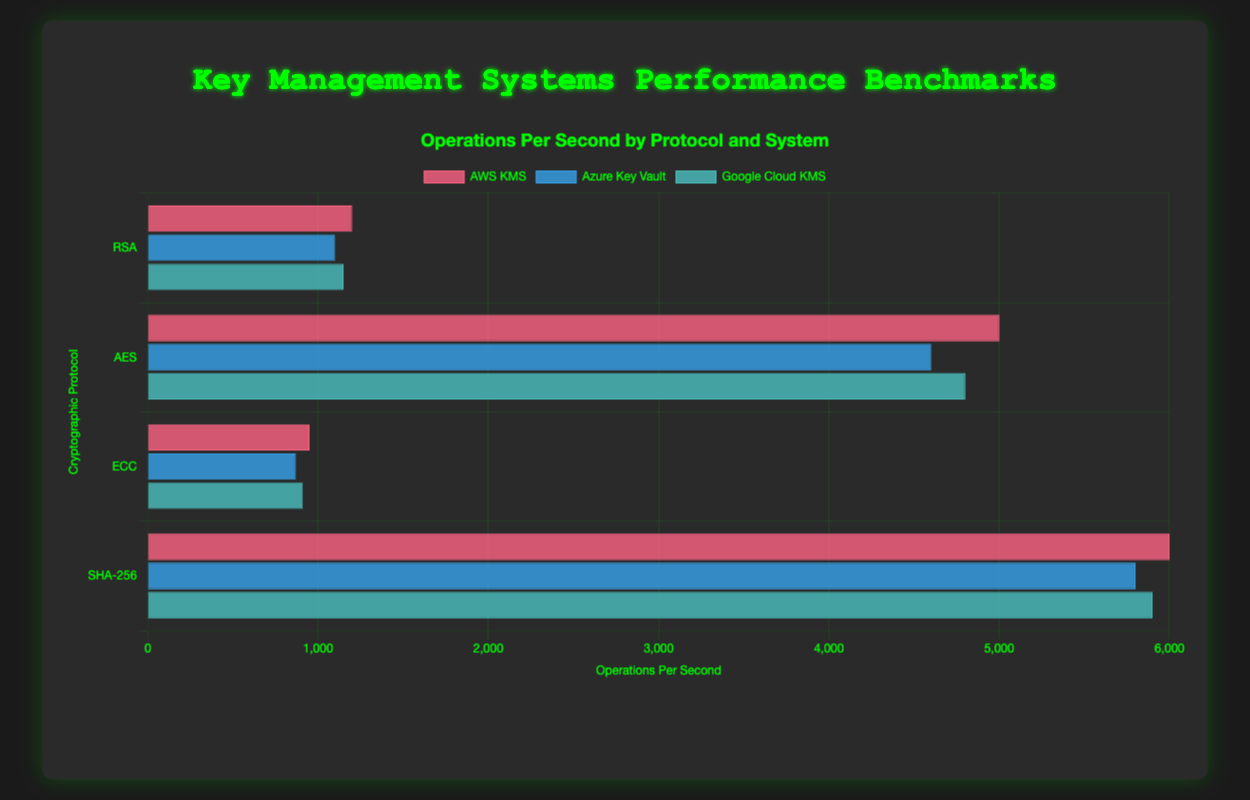Which Key Management System shows the highest operations per second for the RSA protocol? Look at the RSA protocol section and compare the operations per second of AWS KMS, Azure Key Vault, and Google Cloud KMS. AWS KMS has the highest value at 1200 operations per second.
Answer: AWS KMS How does the latency of Google Cloud KMS compare to Azure Key Vault for the AES protocol? For the AES protocol, Google Cloud KMS has a latency of 6 ms while Azure Key Vault has a latency of 7 ms. Google Cloud KMS has lower latency by 1 ms.
Answer: Google Cloud KMS has lower latency Between AWS KMS and Azure Key Vault, which system has a more significant difference in operations per second between AES and ECC protocols? Calculate the difference in operations per second for both systems across AES and ECC. For AWS KMS, the difference is 5000 - 950 = 4050. For Azure Key Vault, the difference is 4600 - 870 = 3730. AWS KMS has a greater difference.
Answer: AWS KMS Which cryptographic protocol has the least variation in operations per second among the three KMS systems? Compare the variation in operations per second within each protocol. For RSA, the range is 1200 - 1100 = 100. For AES, the range is 5000 - 4600 = 400. For ECC, the range is 950 - 870 = 80. For SHA-256, the range is 6000 - 5800 = 200. ECC has the least variation.
Answer: ECC What is the average latency for the RSA protocol across all systems? To find the average, sum the latencies and divide by the number of systems. (20 ms + 25 ms + 22 ms)/3 = 67 ms / 3 = 22.33 ms.
Answer: 22.33 ms Which system has the highest operations per second for the SHA-256 protocol, and what is its value? Refer to the SHA-256 protocol section and identify the system with the highest operations per second. AWS KMS has the highest value at 6000 operations per second.
Answer: AWS KMS, 6000 operations per second Compare the latency of AWS KMS between the RSA and SHA-256 protocols. AWS KMS has a latency of 20 ms for RSA and 4 ms for SHA-256. The latency is lower for the SHA-256 protocol by 16 ms.
Answer: Latency is lower for SHA-256 What is the total number of operations per second for all systems combined under the ECC protocol? Sum the operations per second for AWS KMS, Azure Key Vault, and Google Cloud KMS under the ECC protocol. 950 + 870 + 910 = 2730 operations per second.
Answer: 2730 operations per second Which system has the second highest operations per second for the AES protocol, and what is its latency? Refer to the AES protocol section and identify the second highest operations per second. Google Cloud KMS has the second highest with 4800 operations per second and a latency of 6 ms.
Answer: Google Cloud KMS, 6 ms How does the highest latency for the ECC protocol compare to the lowest latency for the SHA-256 protocol? The highest latency for ECC is 35 ms (Azure Key Vault), and the lowest latency for SHA-256 is 4 ms (AWS KMS). 35 ms is much higher than 4 ms.
Answer: ECC has much higher latency 